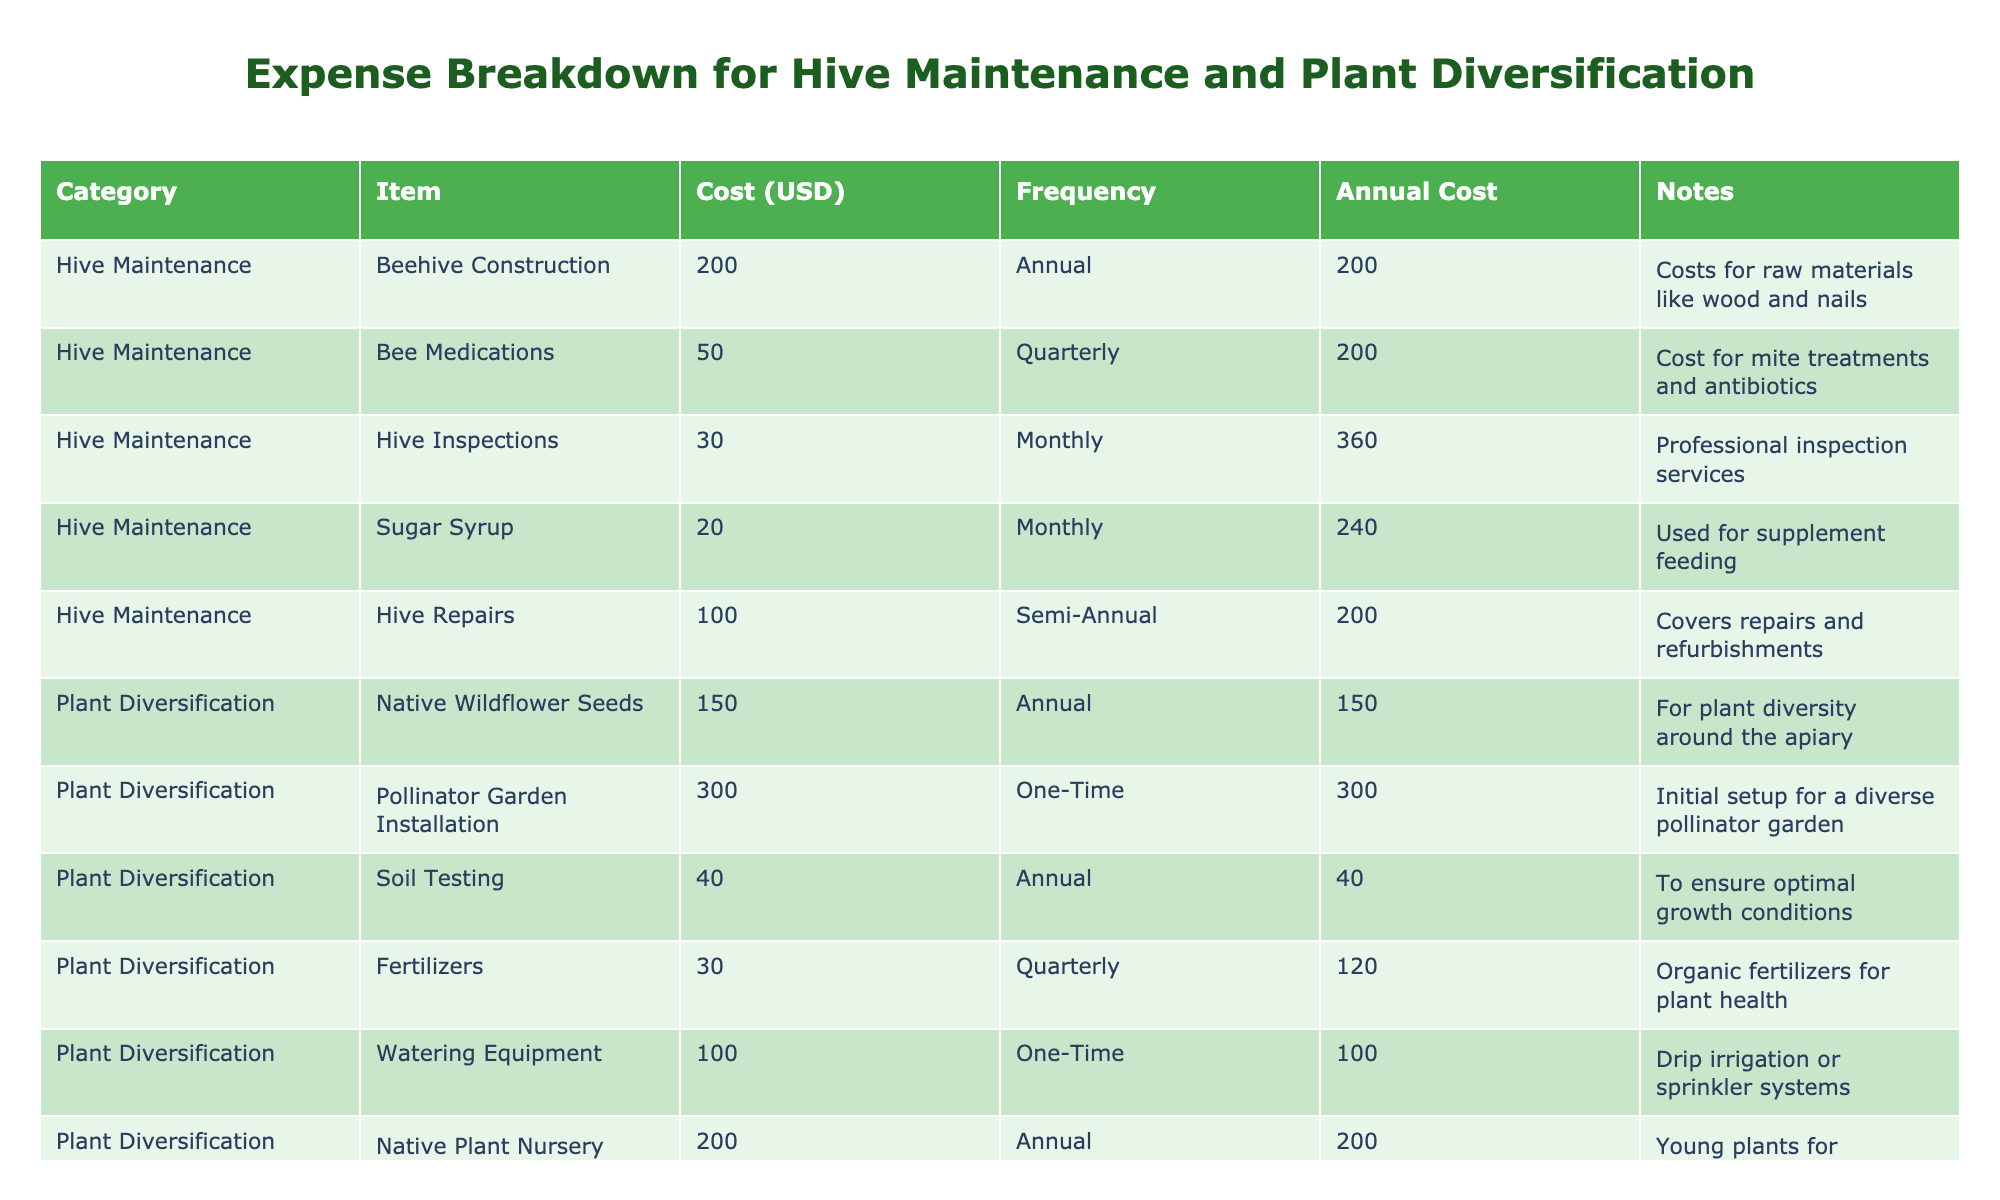What is the total annual cost for hive maintenance? The costs for hive maintenance listed in the table are: Beehive Construction (200), Bee Medications (200), Hive Inspections (360), Sugar Syrup (240), and Hive Repairs (200). Adding these gives 200 + 200 + 360 + 240 + 200 = 1200.
Answer: 1200 How much do you spend on pollinator garden installation? The cost for Pollinator Garden Installation is listed as 300 under Plant Diversification.
Answer: 300 Is the total annual expense for plant diversification more than the total for hive maintenance? The total annual costs for plant diversification include Native Wildflower Seeds (150), Pollinator Garden Installation (300), Soil Testing (40), Fertilizers (120), Watering Equipment (100), and Native Plant Nursery Seedlings (200), which sum to 910. The total for hive maintenance is 1200. Since 910 is less than 1200, the statement is false.
Answer: No What is the highest individual expense listed in the table? The individual expenses are Beehive Construction (200), Bee Medications (200), Hive Inspections (360), Sugar Syrup (240), Hive Repairs (200), Native Wildflower Seeds (150), Pollinator Garden Installation (300), Soil Testing (40), Fertilizers (120), Watering Equipment (100), Native Plant Nursery Seedlings (200), Registration and Licenses (50), Workshops and Training (100), and Marketing and Packaging (150). The highest cost is Hive Inspections at 360.
Answer: 360 What is the average cost for items in the 'Other' category? The 'Other' category items are Registration and Licenses (50), Workshops and Training (100), and Marketing and Packaging (150). Adding these gives 50 + 100 + 150 = 300. Dividing by the number of items (3) gives an average of 300/3 = 100.
Answer: 100 How much do you spend on Sugar Syrup monthly? The Sugar Syrup cost is listed as 20 and it’s a monthly expense.
Answer: 20 Can you identify if hive inspections occur more frequently than fertilizing plants? Hive Inspections occur monthly (12 times a year) while Fertilizers are applied quarterly (4 times a year). Since 12 is greater than 4, the statement is true.
Answer: Yes If I add the costs for Bee Medications and Hive Repairs, what is the result? The costs for Bee Medications is 200 (annual value) and Hive Repairs is also listed as 200 (annual value). Adding these gives 200 + 200 = 400.
Answer: 400 